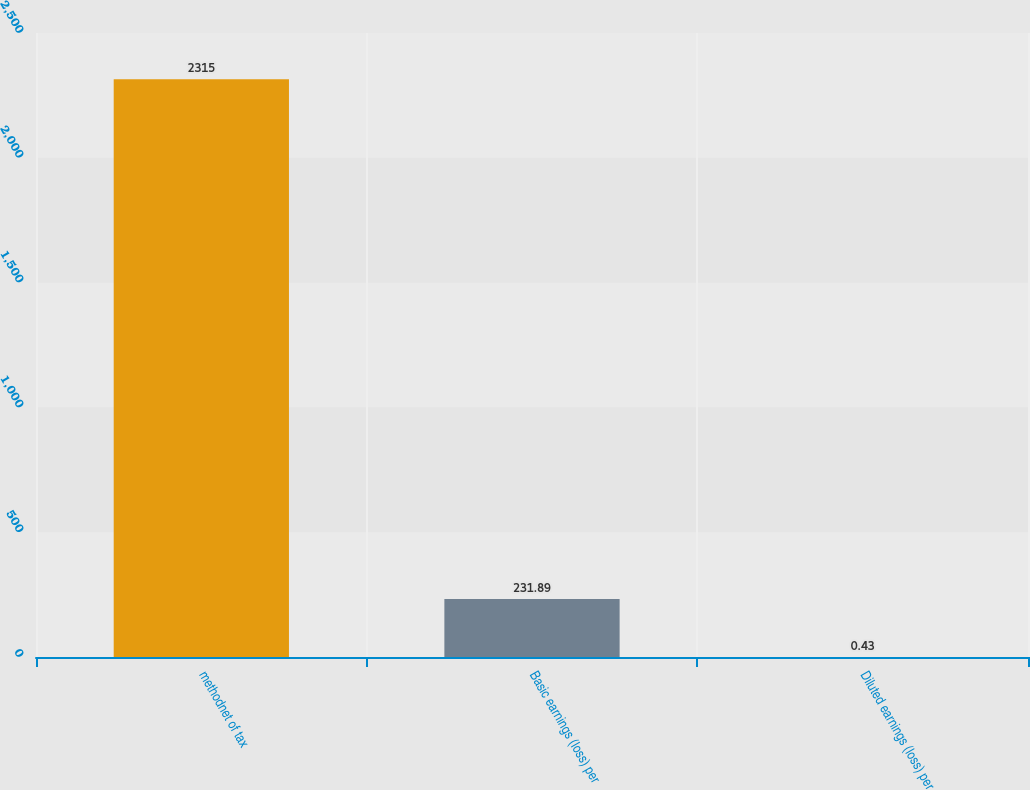Convert chart. <chart><loc_0><loc_0><loc_500><loc_500><bar_chart><fcel>methodnet of tax<fcel>Basic earnings (loss) per<fcel>Diluted earnings (loss) per<nl><fcel>2315<fcel>231.89<fcel>0.43<nl></chart> 